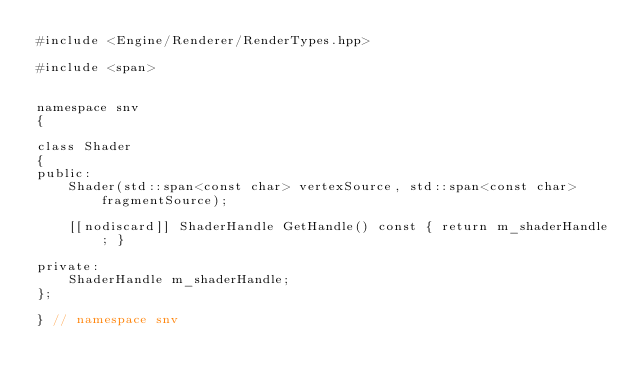Convert code to text. <code><loc_0><loc_0><loc_500><loc_500><_C++_>#include <Engine/Renderer/RenderTypes.hpp>

#include <span>


namespace snv
{

class Shader
{
public:
    Shader(std::span<const char> vertexSource, std::span<const char> fragmentSource);

    [[nodiscard]] ShaderHandle GetHandle() const { return m_shaderHandle; }

private:
    ShaderHandle m_shaderHandle;
};

} // namespace snv
</code> 